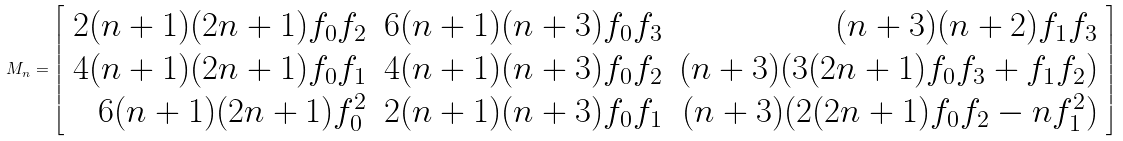Convert formula to latex. <formula><loc_0><loc_0><loc_500><loc_500>M _ { n } = \left [ \begin{array} { r r r } 2 ( n + 1 ) ( 2 n + 1 ) f _ { 0 } f _ { 2 } & 6 ( n + 1 ) ( n + 3 ) f _ { 0 } f _ { 3 } & ( n + 3 ) ( n + 2 ) f _ { 1 } f _ { 3 } \\ 4 ( n + 1 ) ( 2 n + 1 ) f _ { 0 } f _ { 1 } & 4 ( n + 1 ) ( n + 3 ) f _ { 0 } f _ { 2 } & ( n + 3 ) ( 3 ( 2 n + 1 ) f _ { 0 } f _ { 3 } + f _ { 1 } f _ { 2 } ) \\ 6 ( n + 1 ) ( 2 n + 1 ) f _ { 0 } ^ { 2 } & 2 ( n + 1 ) ( n + 3 ) f _ { 0 } f _ { 1 } & ( n + 3 ) ( 2 ( 2 n + 1 ) f _ { 0 } f _ { 2 } - n f _ { 1 } ^ { 2 } ) \end{array} \right ]</formula> 